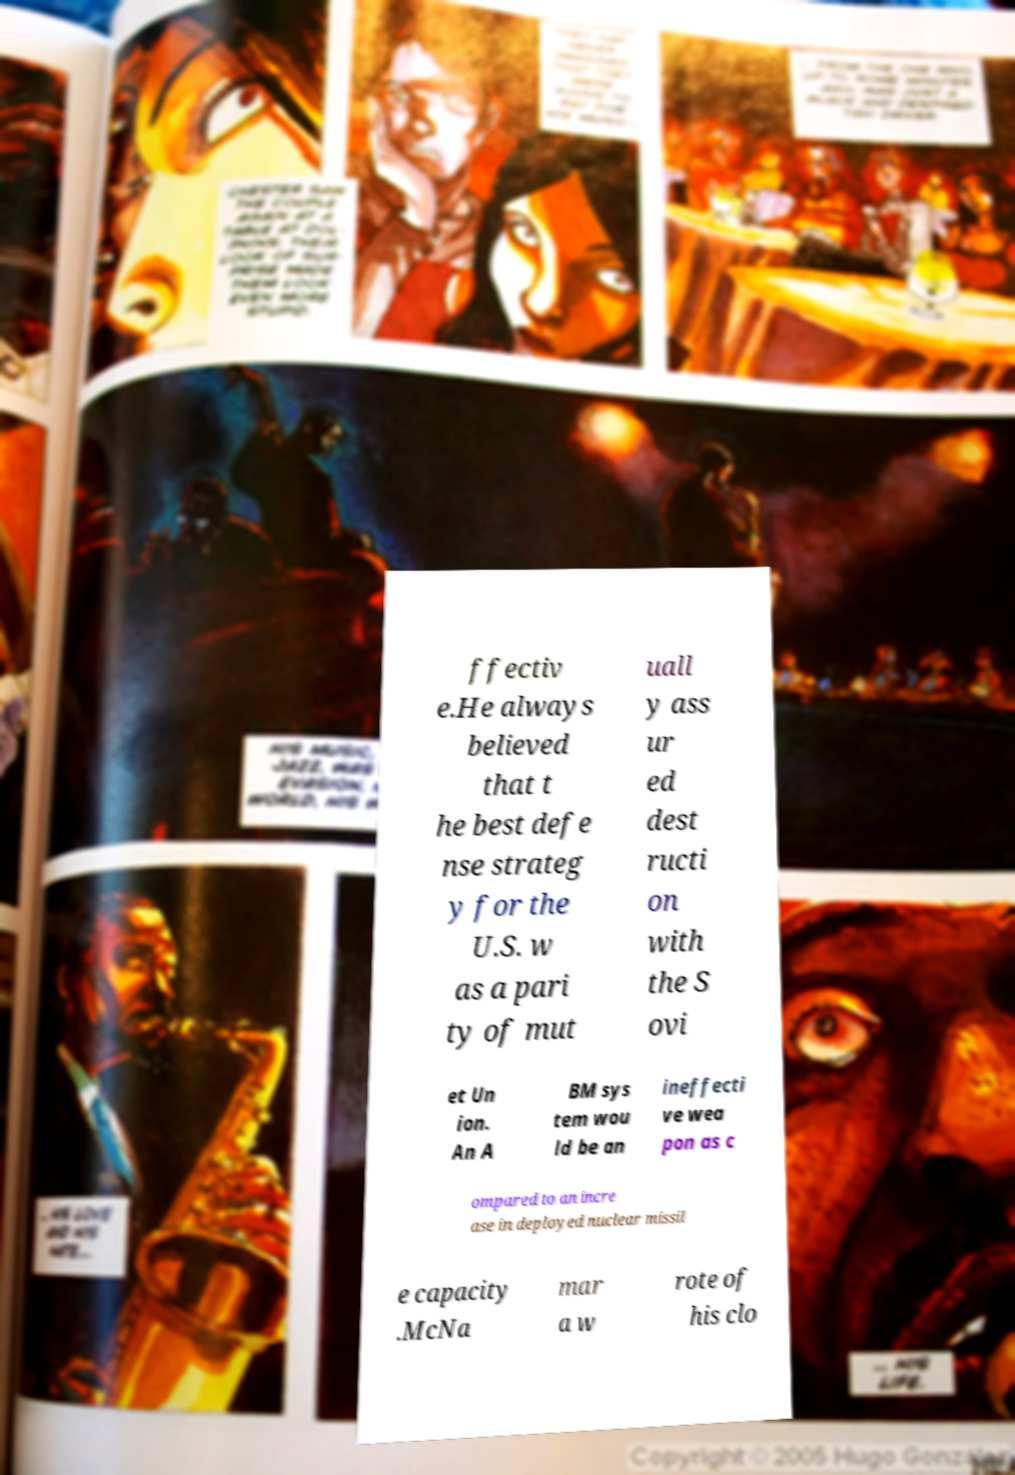Can you read and provide the text displayed in the image?This photo seems to have some interesting text. Can you extract and type it out for me? ffectiv e.He always believed that t he best defe nse strateg y for the U.S. w as a pari ty of mut uall y ass ur ed dest ructi on with the S ovi et Un ion. An A BM sys tem wou ld be an ineffecti ve wea pon as c ompared to an incre ase in deployed nuclear missil e capacity .McNa mar a w rote of his clo 